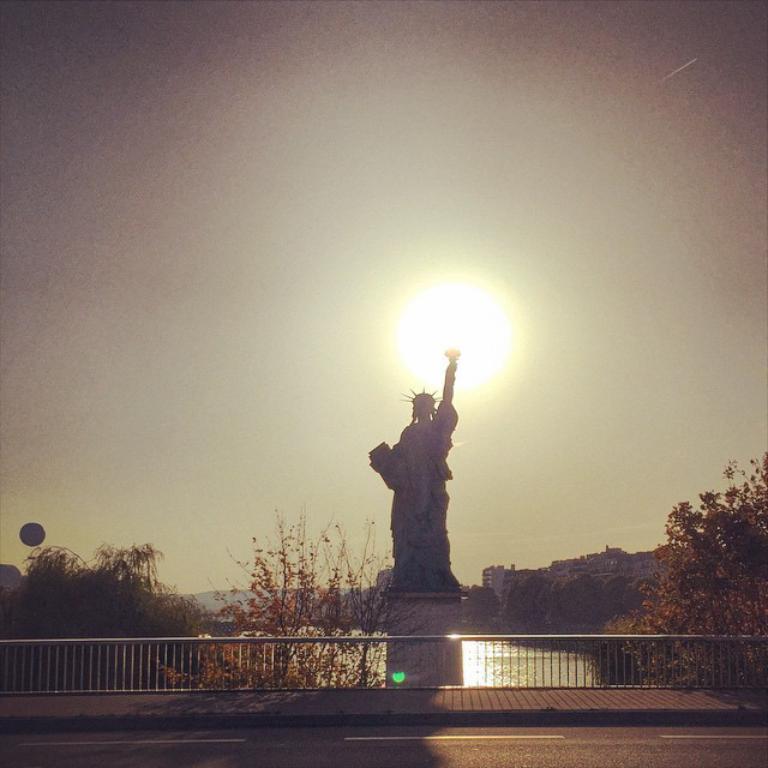Please provide a concise description of this image. In the center of the image, we can see a statue and in the background, there are trees, buildings and there is water and railing and we can see sun in the sky. At the bottom, there is a road. 